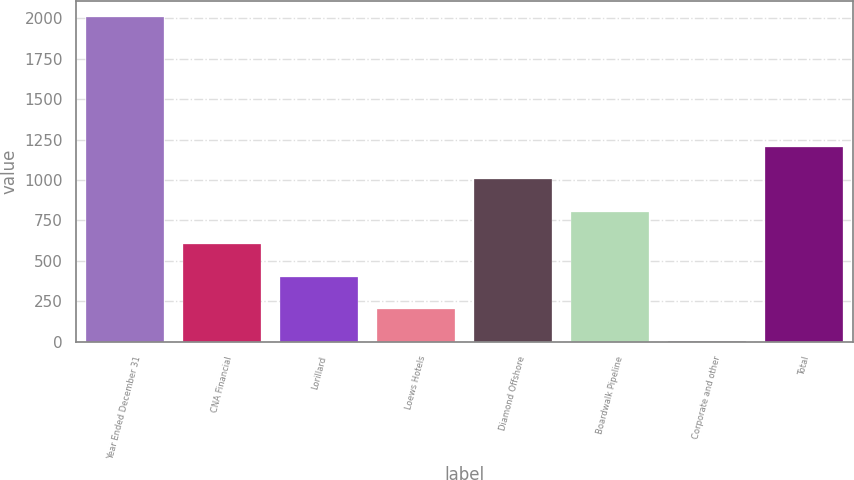Convert chart to OTSL. <chart><loc_0><loc_0><loc_500><loc_500><bar_chart><fcel>Year Ended December 31<fcel>CNA Financial<fcel>Lorillard<fcel>Loews Hotels<fcel>Diamond Offshore<fcel>Boardwalk Pipeline<fcel>Corporate and other<fcel>Total<nl><fcel>2005<fcel>603.6<fcel>403.4<fcel>203.2<fcel>1004<fcel>803.8<fcel>3<fcel>1204.2<nl></chart> 